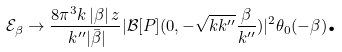<formula> <loc_0><loc_0><loc_500><loc_500>\mathcal { E } _ { \beta } \rightarrow \frac { 8 \pi ^ { 3 } k \, | \beta | \, z } { \, k ^ { \prime \prime } | \bar { \beta } | } | \mathcal { B } [ P ] ( 0 , - \sqrt { k k ^ { \prime \prime } } \frac { \beta } { k ^ { \prime \prime } } ) | ^ { 2 } \theta _ { 0 } ( - \beta ) \text {.}</formula> 